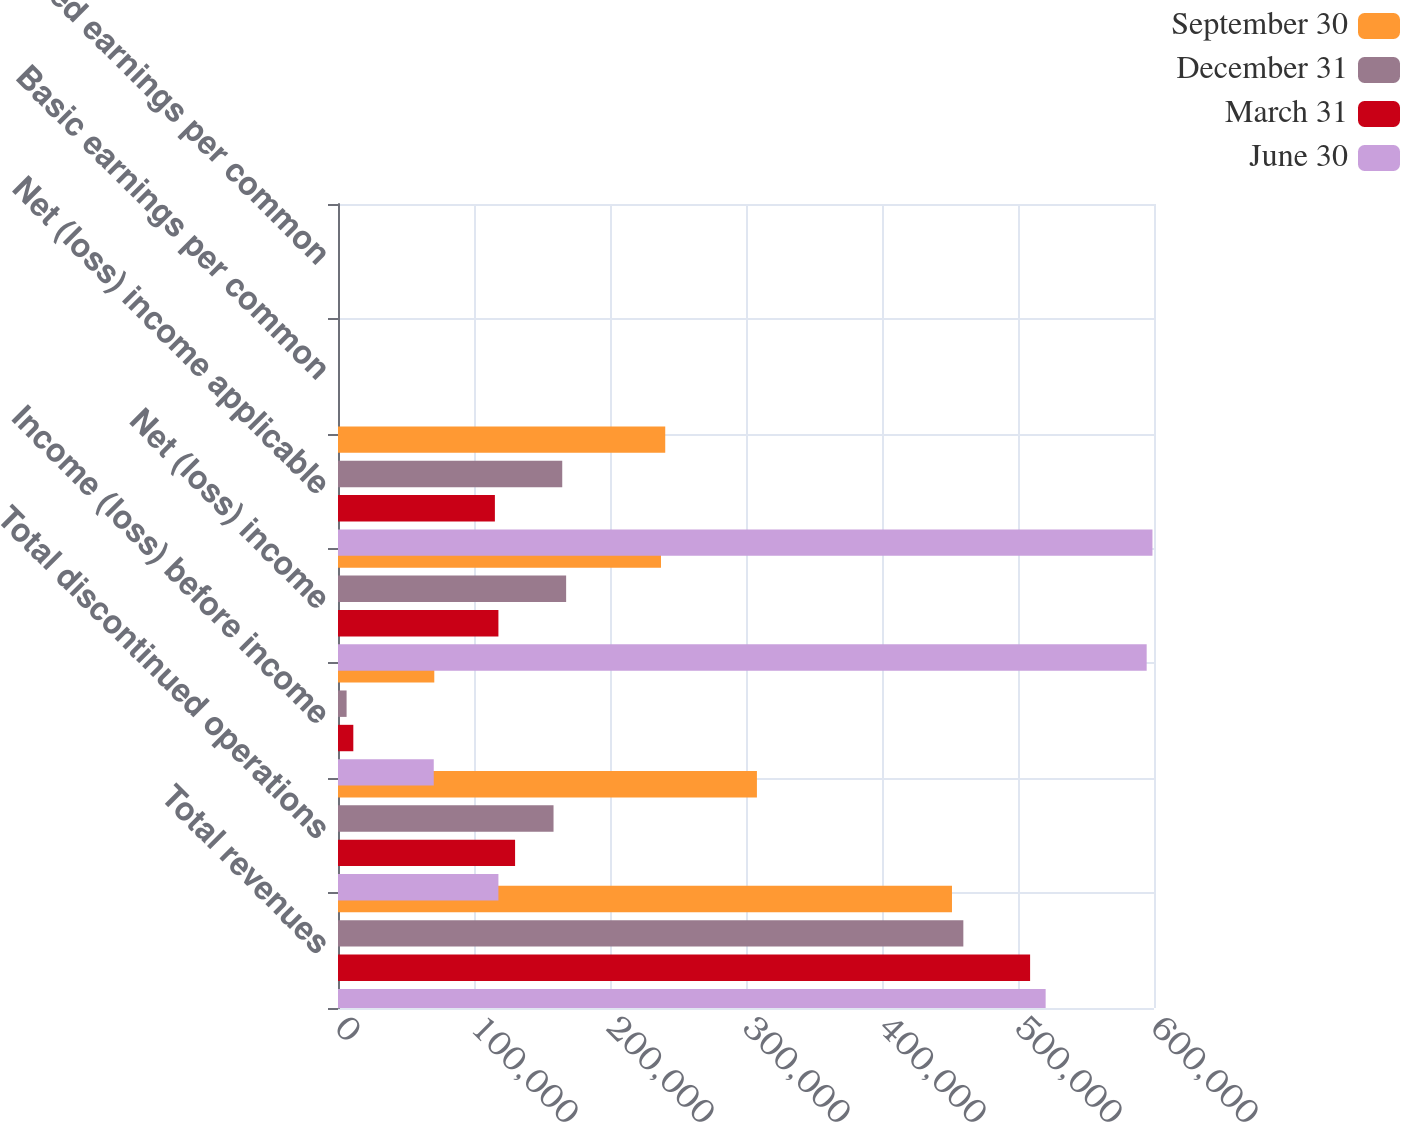Convert chart to OTSL. <chart><loc_0><loc_0><loc_500><loc_500><stacked_bar_chart><ecel><fcel>Total revenues<fcel>Total discontinued operations<fcel>Income (loss) before income<fcel>Net (loss) income<fcel>Net (loss) income applicable<fcel>Basic earnings per common<fcel>Diluted earnings per common<nl><fcel>September 30<fcel>451458<fcel>308028<fcel>70806<fcel>237503<fcel>240614<fcel>0.52<fcel>0.52<nl><fcel>December 31<fcel>459806<fcel>158479<fcel>6320<fcel>167748<fcel>164885<fcel>0.36<fcel>0.36<nl><fcel>March 31<fcel>508900<fcel>130210<fcel>11263<fcel>117954<fcel>115362<fcel>0.25<fcel>0.25<nl><fcel>June 30<fcel>520325<fcel>117954<fcel>70408<fcel>594617<fcel>598868<fcel>1.29<fcel>1.29<nl></chart> 